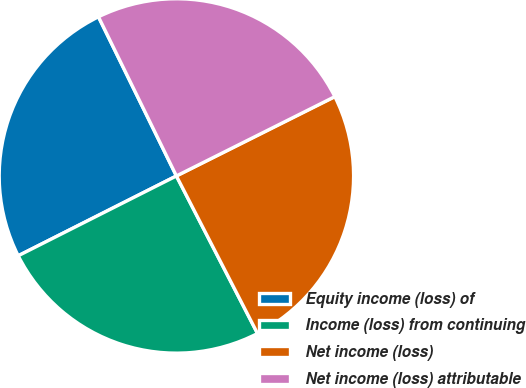<chart> <loc_0><loc_0><loc_500><loc_500><pie_chart><fcel>Equity income (loss) of<fcel>Income (loss) from continuing<fcel>Net income (loss)<fcel>Net income (loss) attributable<nl><fcel>25.19%<fcel>25.13%<fcel>24.82%<fcel>24.86%<nl></chart> 